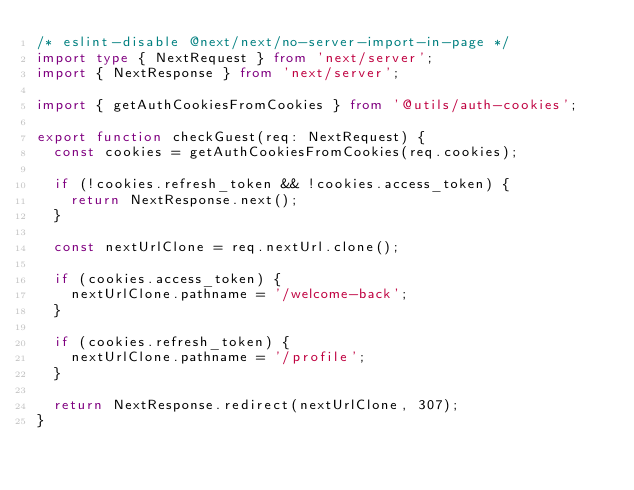Convert code to text. <code><loc_0><loc_0><loc_500><loc_500><_TypeScript_>/* eslint-disable @next/next/no-server-import-in-page */
import type { NextRequest } from 'next/server';
import { NextResponse } from 'next/server';

import { getAuthCookiesFromCookies } from '@utils/auth-cookies';

export function checkGuest(req: NextRequest) {
  const cookies = getAuthCookiesFromCookies(req.cookies);

  if (!cookies.refresh_token && !cookies.access_token) {
    return NextResponse.next();
  }

  const nextUrlClone = req.nextUrl.clone();

  if (cookies.access_token) {
    nextUrlClone.pathname = '/welcome-back';
  }

  if (cookies.refresh_token) {
    nextUrlClone.pathname = '/profile';
  }

  return NextResponse.redirect(nextUrlClone, 307);
}
</code> 